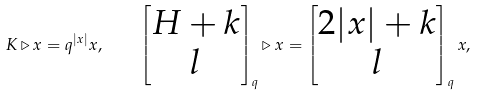Convert formula to latex. <formula><loc_0><loc_0><loc_500><loc_500>K \triangleright x = q ^ { | x | } x , \quad \begin{bmatrix} H + k \\ l \end{bmatrix} _ { q } \triangleright x = \begin{bmatrix} 2 | x | + k \\ l \end{bmatrix} _ { q } x ,</formula> 